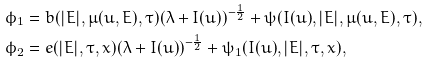<formula> <loc_0><loc_0><loc_500><loc_500>& \phi _ { 1 } = b ( | E | , \mu ( u , E ) , \tau ) ( \lambda + I ( u ) ) ^ { - \frac { 1 } { 2 } } + \psi ( I ( u ) , | E | , \mu ( u , E ) , \tau ) , \\ & \phi _ { 2 } = e ( | E | , \tau , x ) ( \lambda + I ( u ) ) ^ { - \frac { 1 } { 2 } } + \psi _ { 1 } ( I ( u ) , | E | , \tau , x ) ,</formula> 